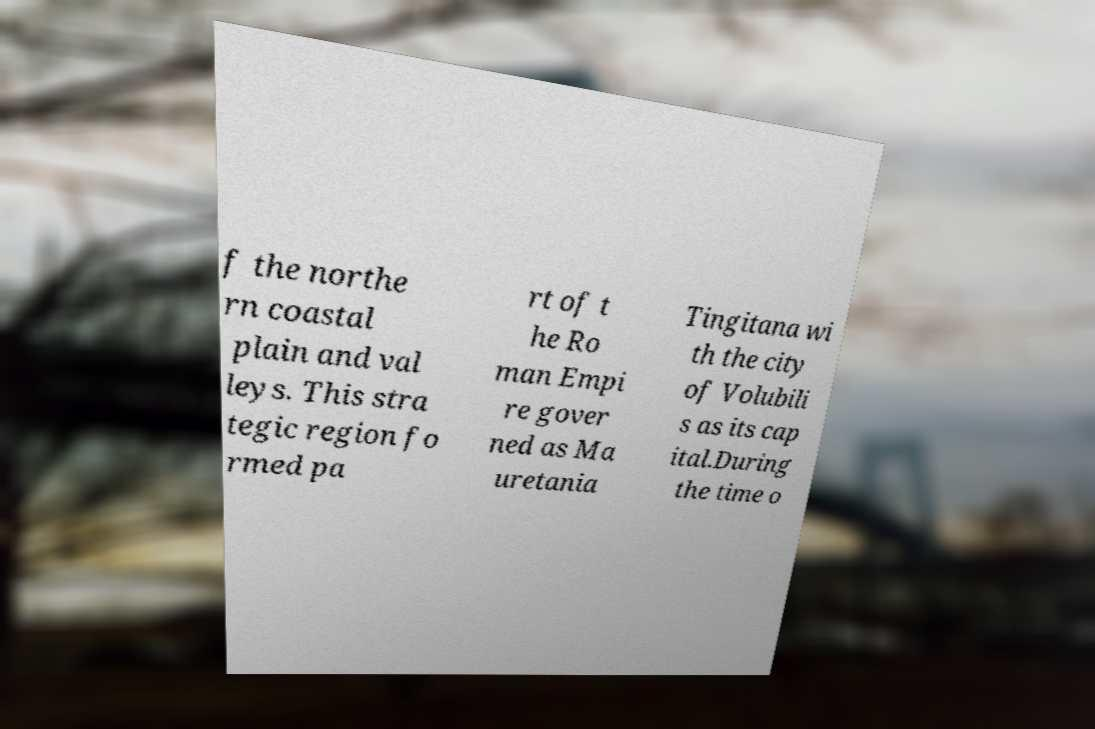There's text embedded in this image that I need extracted. Can you transcribe it verbatim? f the northe rn coastal plain and val leys. This stra tegic region fo rmed pa rt of t he Ro man Empi re gover ned as Ma uretania Tingitana wi th the city of Volubili s as its cap ital.During the time o 